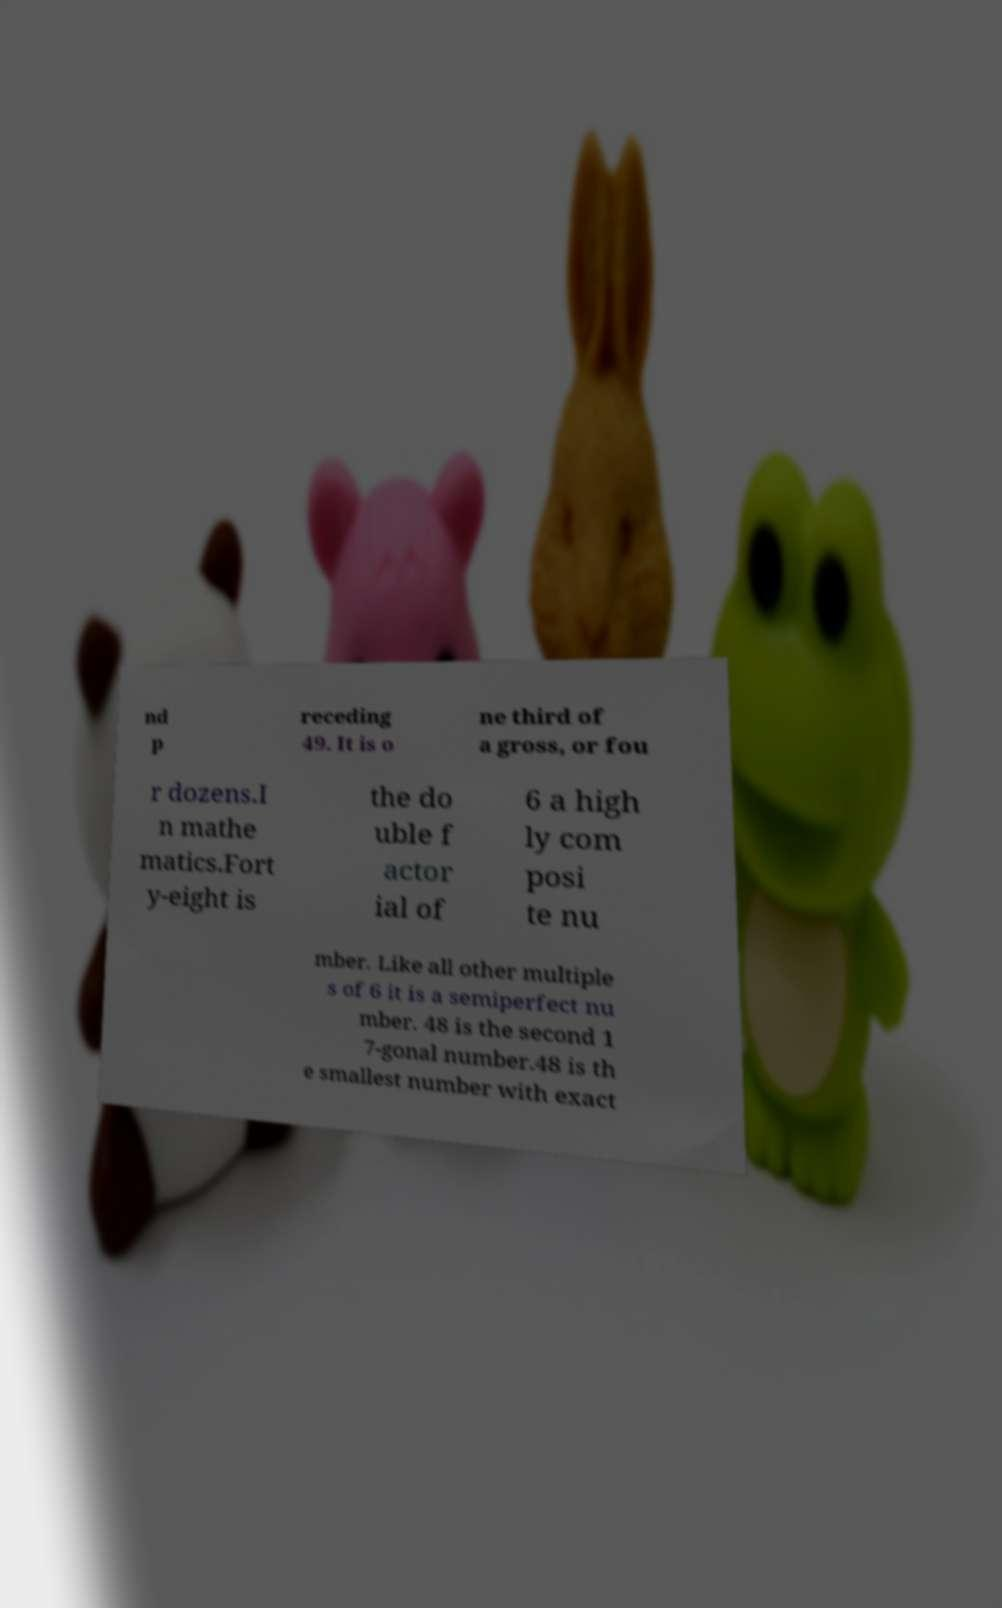I need the written content from this picture converted into text. Can you do that? nd p receding 49. It is o ne third of a gross, or fou r dozens.I n mathe matics.Fort y-eight is the do uble f actor ial of 6 a high ly com posi te nu mber. Like all other multiple s of 6 it is a semiperfect nu mber. 48 is the second 1 7-gonal number.48 is th e smallest number with exact 